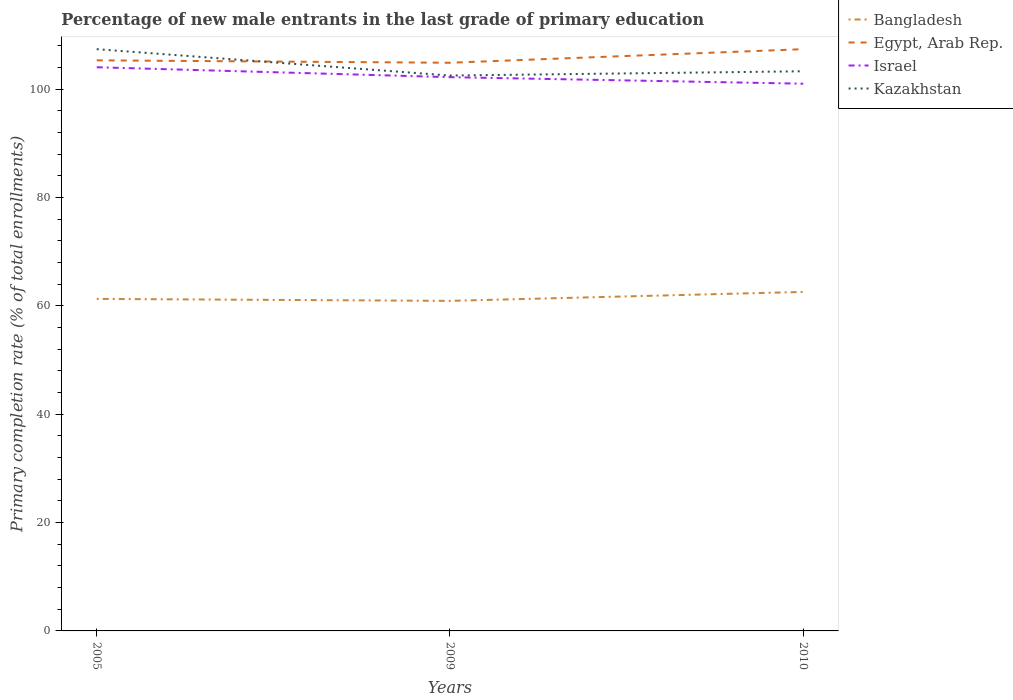How many different coloured lines are there?
Provide a succinct answer. 4. Does the line corresponding to Egypt, Arab Rep. intersect with the line corresponding to Kazakhstan?
Provide a succinct answer. Yes. Is the number of lines equal to the number of legend labels?
Your answer should be compact. Yes. Across all years, what is the maximum percentage of new male entrants in Bangladesh?
Offer a very short reply. 60.94. In which year was the percentage of new male entrants in Israel maximum?
Your answer should be compact. 2010. What is the total percentage of new male entrants in Egypt, Arab Rep. in the graph?
Ensure brevity in your answer.  -2.06. What is the difference between the highest and the second highest percentage of new male entrants in Kazakhstan?
Provide a succinct answer. 4.87. Is the percentage of new male entrants in Israel strictly greater than the percentage of new male entrants in Egypt, Arab Rep. over the years?
Your response must be concise. Yes. Does the graph contain any zero values?
Your answer should be very brief. No. Does the graph contain grids?
Provide a succinct answer. No. Where does the legend appear in the graph?
Offer a terse response. Top right. How are the legend labels stacked?
Your response must be concise. Vertical. What is the title of the graph?
Your answer should be very brief. Percentage of new male entrants in the last grade of primary education. What is the label or title of the Y-axis?
Provide a succinct answer. Primary completion rate (% of total enrollments). What is the Primary completion rate (% of total enrollments) in Bangladesh in 2005?
Give a very brief answer. 61.3. What is the Primary completion rate (% of total enrollments) of Egypt, Arab Rep. in 2005?
Your answer should be compact. 105.35. What is the Primary completion rate (% of total enrollments) in Israel in 2005?
Ensure brevity in your answer.  104.07. What is the Primary completion rate (% of total enrollments) of Kazakhstan in 2005?
Offer a terse response. 107.41. What is the Primary completion rate (% of total enrollments) in Bangladesh in 2009?
Provide a short and direct response. 60.94. What is the Primary completion rate (% of total enrollments) in Egypt, Arab Rep. in 2009?
Make the answer very short. 104.9. What is the Primary completion rate (% of total enrollments) of Israel in 2009?
Offer a very short reply. 102.24. What is the Primary completion rate (% of total enrollments) in Kazakhstan in 2009?
Ensure brevity in your answer.  102.54. What is the Primary completion rate (% of total enrollments) in Bangladesh in 2010?
Make the answer very short. 62.59. What is the Primary completion rate (% of total enrollments) in Egypt, Arab Rep. in 2010?
Give a very brief answer. 107.41. What is the Primary completion rate (% of total enrollments) in Israel in 2010?
Your response must be concise. 101.03. What is the Primary completion rate (% of total enrollments) of Kazakhstan in 2010?
Provide a short and direct response. 103.33. Across all years, what is the maximum Primary completion rate (% of total enrollments) in Bangladesh?
Give a very brief answer. 62.59. Across all years, what is the maximum Primary completion rate (% of total enrollments) in Egypt, Arab Rep.?
Provide a succinct answer. 107.41. Across all years, what is the maximum Primary completion rate (% of total enrollments) in Israel?
Offer a very short reply. 104.07. Across all years, what is the maximum Primary completion rate (% of total enrollments) of Kazakhstan?
Provide a short and direct response. 107.41. Across all years, what is the minimum Primary completion rate (% of total enrollments) of Bangladesh?
Provide a short and direct response. 60.94. Across all years, what is the minimum Primary completion rate (% of total enrollments) in Egypt, Arab Rep.?
Give a very brief answer. 104.9. Across all years, what is the minimum Primary completion rate (% of total enrollments) in Israel?
Provide a succinct answer. 101.03. Across all years, what is the minimum Primary completion rate (% of total enrollments) in Kazakhstan?
Keep it short and to the point. 102.54. What is the total Primary completion rate (% of total enrollments) of Bangladesh in the graph?
Your answer should be compact. 184.83. What is the total Primary completion rate (% of total enrollments) in Egypt, Arab Rep. in the graph?
Ensure brevity in your answer.  317.65. What is the total Primary completion rate (% of total enrollments) of Israel in the graph?
Your response must be concise. 307.34. What is the total Primary completion rate (% of total enrollments) in Kazakhstan in the graph?
Make the answer very short. 313.27. What is the difference between the Primary completion rate (% of total enrollments) of Bangladesh in 2005 and that in 2009?
Keep it short and to the point. 0.36. What is the difference between the Primary completion rate (% of total enrollments) of Egypt, Arab Rep. in 2005 and that in 2009?
Make the answer very short. 0.45. What is the difference between the Primary completion rate (% of total enrollments) in Israel in 2005 and that in 2009?
Provide a short and direct response. 1.83. What is the difference between the Primary completion rate (% of total enrollments) in Kazakhstan in 2005 and that in 2009?
Provide a short and direct response. 4.87. What is the difference between the Primary completion rate (% of total enrollments) in Bangladesh in 2005 and that in 2010?
Your response must be concise. -1.29. What is the difference between the Primary completion rate (% of total enrollments) of Egypt, Arab Rep. in 2005 and that in 2010?
Offer a very short reply. -2.06. What is the difference between the Primary completion rate (% of total enrollments) in Israel in 2005 and that in 2010?
Provide a succinct answer. 3.04. What is the difference between the Primary completion rate (% of total enrollments) of Kazakhstan in 2005 and that in 2010?
Your answer should be very brief. 4.08. What is the difference between the Primary completion rate (% of total enrollments) in Bangladesh in 2009 and that in 2010?
Give a very brief answer. -1.65. What is the difference between the Primary completion rate (% of total enrollments) of Egypt, Arab Rep. in 2009 and that in 2010?
Give a very brief answer. -2.51. What is the difference between the Primary completion rate (% of total enrollments) in Israel in 2009 and that in 2010?
Offer a very short reply. 1.21. What is the difference between the Primary completion rate (% of total enrollments) in Kazakhstan in 2009 and that in 2010?
Offer a very short reply. -0.79. What is the difference between the Primary completion rate (% of total enrollments) in Bangladesh in 2005 and the Primary completion rate (% of total enrollments) in Egypt, Arab Rep. in 2009?
Keep it short and to the point. -43.6. What is the difference between the Primary completion rate (% of total enrollments) of Bangladesh in 2005 and the Primary completion rate (% of total enrollments) of Israel in 2009?
Provide a succinct answer. -40.94. What is the difference between the Primary completion rate (% of total enrollments) in Bangladesh in 2005 and the Primary completion rate (% of total enrollments) in Kazakhstan in 2009?
Your answer should be compact. -41.24. What is the difference between the Primary completion rate (% of total enrollments) in Egypt, Arab Rep. in 2005 and the Primary completion rate (% of total enrollments) in Israel in 2009?
Offer a very short reply. 3.11. What is the difference between the Primary completion rate (% of total enrollments) in Egypt, Arab Rep. in 2005 and the Primary completion rate (% of total enrollments) in Kazakhstan in 2009?
Provide a succinct answer. 2.81. What is the difference between the Primary completion rate (% of total enrollments) in Israel in 2005 and the Primary completion rate (% of total enrollments) in Kazakhstan in 2009?
Make the answer very short. 1.53. What is the difference between the Primary completion rate (% of total enrollments) in Bangladesh in 2005 and the Primary completion rate (% of total enrollments) in Egypt, Arab Rep. in 2010?
Your answer should be compact. -46.11. What is the difference between the Primary completion rate (% of total enrollments) of Bangladesh in 2005 and the Primary completion rate (% of total enrollments) of Israel in 2010?
Keep it short and to the point. -39.73. What is the difference between the Primary completion rate (% of total enrollments) in Bangladesh in 2005 and the Primary completion rate (% of total enrollments) in Kazakhstan in 2010?
Give a very brief answer. -42.03. What is the difference between the Primary completion rate (% of total enrollments) of Egypt, Arab Rep. in 2005 and the Primary completion rate (% of total enrollments) of Israel in 2010?
Ensure brevity in your answer.  4.32. What is the difference between the Primary completion rate (% of total enrollments) of Egypt, Arab Rep. in 2005 and the Primary completion rate (% of total enrollments) of Kazakhstan in 2010?
Your answer should be compact. 2.02. What is the difference between the Primary completion rate (% of total enrollments) in Israel in 2005 and the Primary completion rate (% of total enrollments) in Kazakhstan in 2010?
Offer a very short reply. 0.74. What is the difference between the Primary completion rate (% of total enrollments) in Bangladesh in 2009 and the Primary completion rate (% of total enrollments) in Egypt, Arab Rep. in 2010?
Offer a terse response. -46.47. What is the difference between the Primary completion rate (% of total enrollments) in Bangladesh in 2009 and the Primary completion rate (% of total enrollments) in Israel in 2010?
Your answer should be compact. -40.09. What is the difference between the Primary completion rate (% of total enrollments) in Bangladesh in 2009 and the Primary completion rate (% of total enrollments) in Kazakhstan in 2010?
Provide a short and direct response. -42.39. What is the difference between the Primary completion rate (% of total enrollments) in Egypt, Arab Rep. in 2009 and the Primary completion rate (% of total enrollments) in Israel in 2010?
Give a very brief answer. 3.87. What is the difference between the Primary completion rate (% of total enrollments) in Egypt, Arab Rep. in 2009 and the Primary completion rate (% of total enrollments) in Kazakhstan in 2010?
Provide a succinct answer. 1.57. What is the difference between the Primary completion rate (% of total enrollments) in Israel in 2009 and the Primary completion rate (% of total enrollments) in Kazakhstan in 2010?
Your response must be concise. -1.09. What is the average Primary completion rate (% of total enrollments) of Bangladesh per year?
Give a very brief answer. 61.61. What is the average Primary completion rate (% of total enrollments) in Egypt, Arab Rep. per year?
Provide a short and direct response. 105.88. What is the average Primary completion rate (% of total enrollments) in Israel per year?
Keep it short and to the point. 102.45. What is the average Primary completion rate (% of total enrollments) of Kazakhstan per year?
Your answer should be very brief. 104.42. In the year 2005, what is the difference between the Primary completion rate (% of total enrollments) of Bangladesh and Primary completion rate (% of total enrollments) of Egypt, Arab Rep.?
Ensure brevity in your answer.  -44.05. In the year 2005, what is the difference between the Primary completion rate (% of total enrollments) of Bangladesh and Primary completion rate (% of total enrollments) of Israel?
Offer a terse response. -42.77. In the year 2005, what is the difference between the Primary completion rate (% of total enrollments) of Bangladesh and Primary completion rate (% of total enrollments) of Kazakhstan?
Make the answer very short. -46.11. In the year 2005, what is the difference between the Primary completion rate (% of total enrollments) in Egypt, Arab Rep. and Primary completion rate (% of total enrollments) in Israel?
Your answer should be compact. 1.28. In the year 2005, what is the difference between the Primary completion rate (% of total enrollments) of Egypt, Arab Rep. and Primary completion rate (% of total enrollments) of Kazakhstan?
Your response must be concise. -2.06. In the year 2005, what is the difference between the Primary completion rate (% of total enrollments) of Israel and Primary completion rate (% of total enrollments) of Kazakhstan?
Your answer should be very brief. -3.34. In the year 2009, what is the difference between the Primary completion rate (% of total enrollments) in Bangladesh and Primary completion rate (% of total enrollments) in Egypt, Arab Rep.?
Make the answer very short. -43.96. In the year 2009, what is the difference between the Primary completion rate (% of total enrollments) in Bangladesh and Primary completion rate (% of total enrollments) in Israel?
Make the answer very short. -41.3. In the year 2009, what is the difference between the Primary completion rate (% of total enrollments) of Bangladesh and Primary completion rate (% of total enrollments) of Kazakhstan?
Make the answer very short. -41.6. In the year 2009, what is the difference between the Primary completion rate (% of total enrollments) in Egypt, Arab Rep. and Primary completion rate (% of total enrollments) in Israel?
Make the answer very short. 2.66. In the year 2009, what is the difference between the Primary completion rate (% of total enrollments) in Egypt, Arab Rep. and Primary completion rate (% of total enrollments) in Kazakhstan?
Offer a terse response. 2.36. In the year 2009, what is the difference between the Primary completion rate (% of total enrollments) in Israel and Primary completion rate (% of total enrollments) in Kazakhstan?
Ensure brevity in your answer.  -0.3. In the year 2010, what is the difference between the Primary completion rate (% of total enrollments) in Bangladesh and Primary completion rate (% of total enrollments) in Egypt, Arab Rep.?
Provide a succinct answer. -44.82. In the year 2010, what is the difference between the Primary completion rate (% of total enrollments) of Bangladesh and Primary completion rate (% of total enrollments) of Israel?
Give a very brief answer. -38.44. In the year 2010, what is the difference between the Primary completion rate (% of total enrollments) of Bangladesh and Primary completion rate (% of total enrollments) of Kazakhstan?
Make the answer very short. -40.74. In the year 2010, what is the difference between the Primary completion rate (% of total enrollments) of Egypt, Arab Rep. and Primary completion rate (% of total enrollments) of Israel?
Keep it short and to the point. 6.37. In the year 2010, what is the difference between the Primary completion rate (% of total enrollments) of Egypt, Arab Rep. and Primary completion rate (% of total enrollments) of Kazakhstan?
Keep it short and to the point. 4.08. In the year 2010, what is the difference between the Primary completion rate (% of total enrollments) of Israel and Primary completion rate (% of total enrollments) of Kazakhstan?
Keep it short and to the point. -2.3. What is the ratio of the Primary completion rate (% of total enrollments) in Bangladesh in 2005 to that in 2009?
Your answer should be compact. 1.01. What is the ratio of the Primary completion rate (% of total enrollments) of Israel in 2005 to that in 2009?
Your answer should be compact. 1.02. What is the ratio of the Primary completion rate (% of total enrollments) in Kazakhstan in 2005 to that in 2009?
Keep it short and to the point. 1.05. What is the ratio of the Primary completion rate (% of total enrollments) of Bangladesh in 2005 to that in 2010?
Give a very brief answer. 0.98. What is the ratio of the Primary completion rate (% of total enrollments) of Egypt, Arab Rep. in 2005 to that in 2010?
Your answer should be compact. 0.98. What is the ratio of the Primary completion rate (% of total enrollments) in Israel in 2005 to that in 2010?
Provide a succinct answer. 1.03. What is the ratio of the Primary completion rate (% of total enrollments) of Kazakhstan in 2005 to that in 2010?
Your answer should be very brief. 1.04. What is the ratio of the Primary completion rate (% of total enrollments) in Bangladesh in 2009 to that in 2010?
Offer a terse response. 0.97. What is the ratio of the Primary completion rate (% of total enrollments) in Egypt, Arab Rep. in 2009 to that in 2010?
Make the answer very short. 0.98. What is the ratio of the Primary completion rate (% of total enrollments) in Kazakhstan in 2009 to that in 2010?
Give a very brief answer. 0.99. What is the difference between the highest and the second highest Primary completion rate (% of total enrollments) of Bangladesh?
Your response must be concise. 1.29. What is the difference between the highest and the second highest Primary completion rate (% of total enrollments) in Egypt, Arab Rep.?
Your response must be concise. 2.06. What is the difference between the highest and the second highest Primary completion rate (% of total enrollments) of Israel?
Offer a very short reply. 1.83. What is the difference between the highest and the second highest Primary completion rate (% of total enrollments) of Kazakhstan?
Ensure brevity in your answer.  4.08. What is the difference between the highest and the lowest Primary completion rate (% of total enrollments) of Bangladesh?
Provide a succinct answer. 1.65. What is the difference between the highest and the lowest Primary completion rate (% of total enrollments) in Egypt, Arab Rep.?
Your answer should be compact. 2.51. What is the difference between the highest and the lowest Primary completion rate (% of total enrollments) in Israel?
Give a very brief answer. 3.04. What is the difference between the highest and the lowest Primary completion rate (% of total enrollments) of Kazakhstan?
Give a very brief answer. 4.87. 